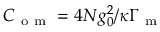Convert formula to latex. <formula><loc_0><loc_0><loc_500><loc_500>C _ { o m } = 4 N g _ { 0 } ^ { 2 } / \kappa \Gamma _ { m }</formula> 